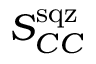<formula> <loc_0><loc_0><loc_500><loc_500>S _ { C C } ^ { s q z }</formula> 